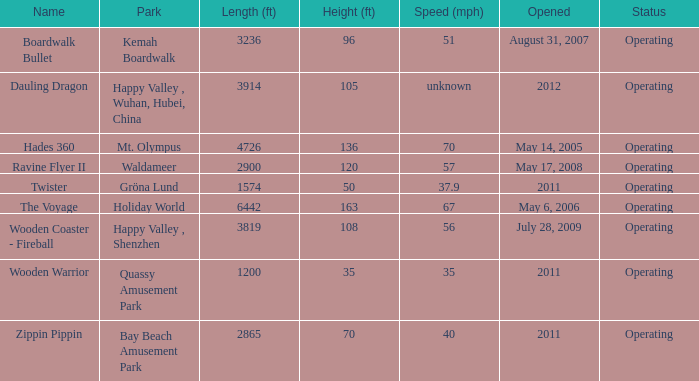What is the distance covered by the roller coaster with an unspecified velocity? 3914.0. Could you parse the entire table as a dict? {'header': ['Name', 'Park', 'Length (ft)', 'Height (ft)', 'Speed (mph)', 'Opened', 'Status'], 'rows': [['Boardwalk Bullet', 'Kemah Boardwalk', '3236', '96', '51', 'August 31, 2007', 'Operating'], ['Dauling Dragon', 'Happy Valley , Wuhan, Hubei, China', '3914', '105', 'unknown', '2012', 'Operating'], ['Hades 360', 'Mt. Olympus', '4726', '136', '70', 'May 14, 2005', 'Operating'], ['Ravine Flyer II', 'Waldameer', '2900', '120', '57', 'May 17, 2008', 'Operating'], ['Twister', 'Gröna Lund', '1574', '50', '37.9', '2011', 'Operating'], ['The Voyage', 'Holiday World', '6442', '163', '67', 'May 6, 2006', 'Operating'], ['Wooden Coaster - Fireball', 'Happy Valley , Shenzhen', '3819', '108', '56', 'July 28, 2009', 'Operating'], ['Wooden Warrior', 'Quassy Amusement Park', '1200', '35', '35', '2011', 'Operating'], ['Zippin Pippin', 'Bay Beach Amusement Park', '2865', '70', '40', '2011', 'Operating']]} 